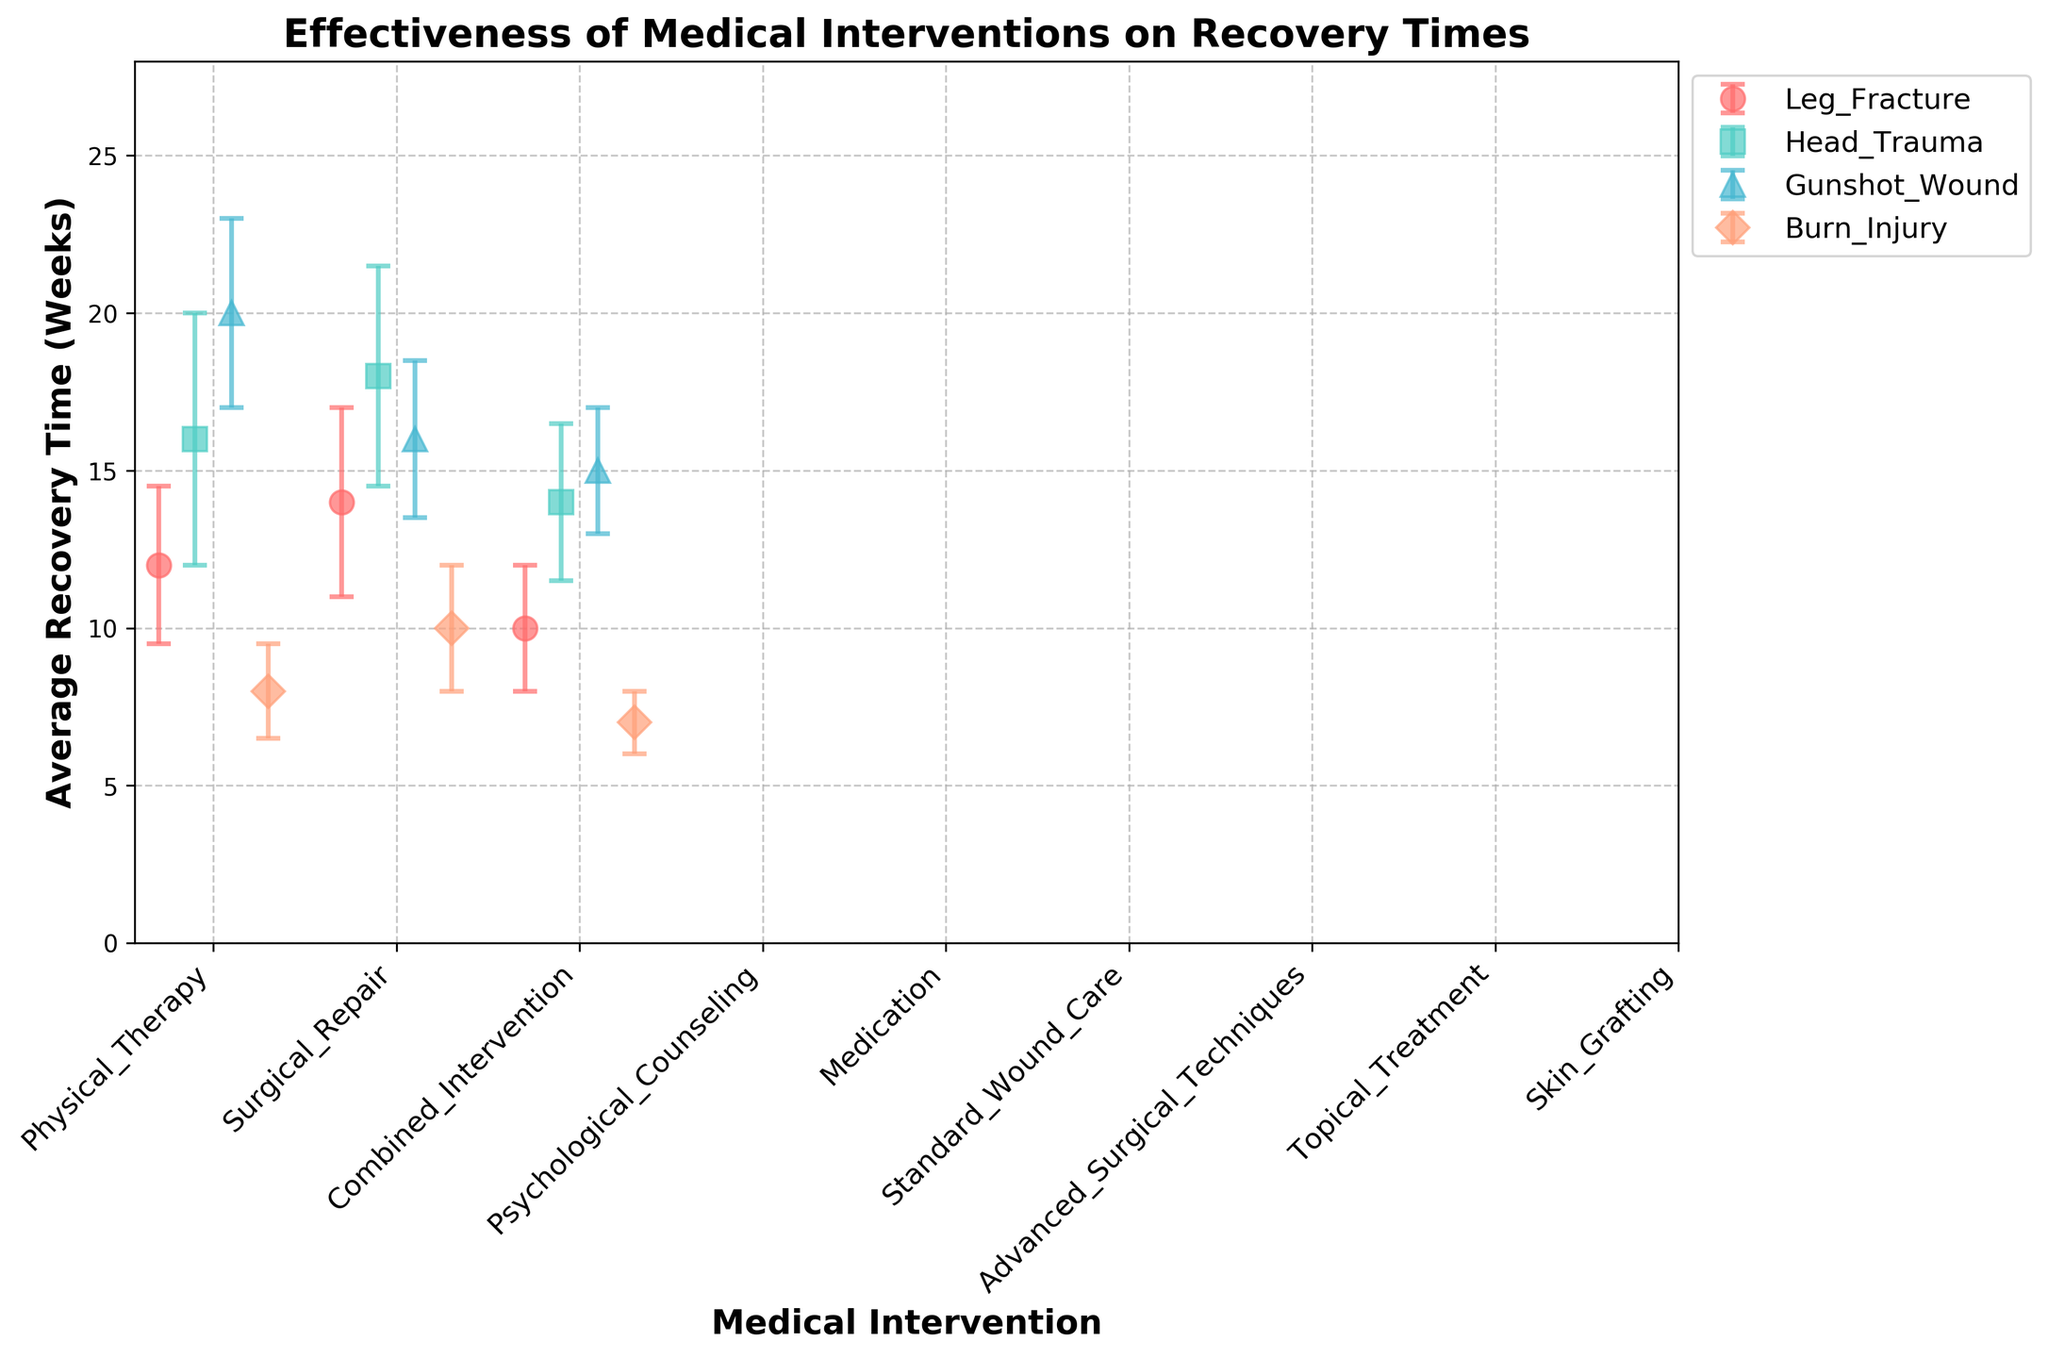What's the title of the plot? The title is located at the top of the plot, prominently displayed to summarize the plotted information.
Answer: Effectiveness of Medical Interventions on Recovery Times How many types of medical interventions are plotted? The types of medical interventions can be identified by counting the unique x-tick labels along the x-axis.
Answer: 12 What is the average recovery time for 'Topical Treatment' in 'Burn Injury'? Look for the point corresponding to 'Topical Treatment' under 'Burn Injury' and read the average recovery time value.
Answer: 8 weeks Which injury type has the longest average recovery time with 'Standard Wound Care'? Compare the average recovery times of 'Standard Wound Care' across different injury types and identify the longest one.
Answer: Gunshot Wound What are the Y-axis limits of the plot? Look at the minimum and maximum values displayed along the Y-axis.
Answer: 0 to 25 What is the difference in recovery time between 'Physical Therapy' and 'Surgical Repair' for 'Leg Fracture'? Subtract the average recovery time for 'Physical Therapy' from 'Surgical Repair' for 'Leg Fracture'.
Answer: 2 weeks Which intervention has the lowest average recovery time for 'Head Trauma'? Look for the lowest point among the interventions for 'Head Trauma'.
Answer: Combined Intervention Which intervention for 'Burn Injury' has the smallest error bar? Compare the lengths of the error bars for each intervention within 'Burn Injury'.
Answer: Combined Intervention What is the total range of recovery times (considering error bars) for 'Psychological Counseling' in 'Head Trauma'? Add the standard deviation to the mean to find the upper limit and subtract it from the mean to find the lower limit, then calculate the range.
Answer: 12 to 20 weeks How does 'Combined Intervention' for 'Gunshot Wound' compare to 'Combined Intervention' for 'Head Trauma' in terms of average recovery time? Compare the average recovery times of 'Combined Intervention' for both 'Gunshot Wound' and 'Head Trauma'.
Answer: Head Trauma has 1 week longer average recovery time than Gunshot Wound 